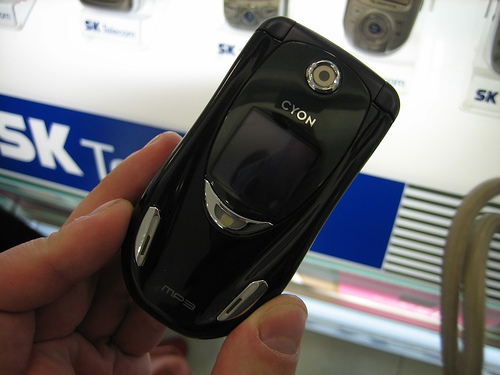Read all the text in this image. CYON mp3 SK SK 